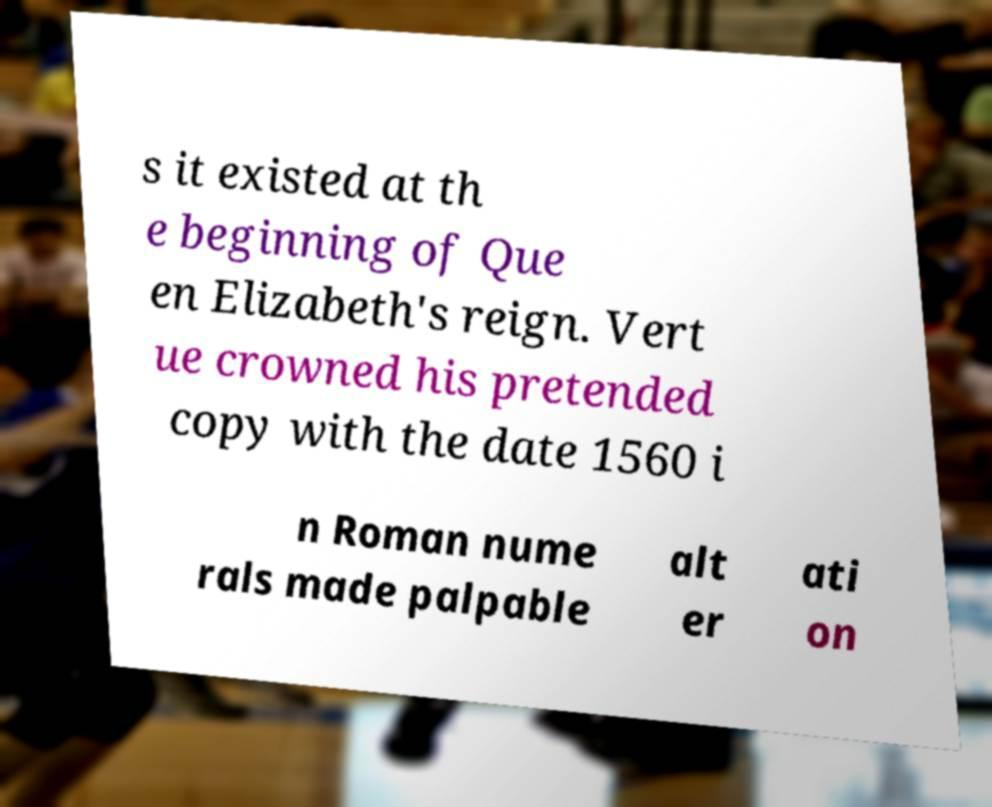Could you assist in decoding the text presented in this image and type it out clearly? s it existed at th e beginning of Que en Elizabeth's reign. Vert ue crowned his pretended copy with the date 1560 i n Roman nume rals made palpable alt er ati on 